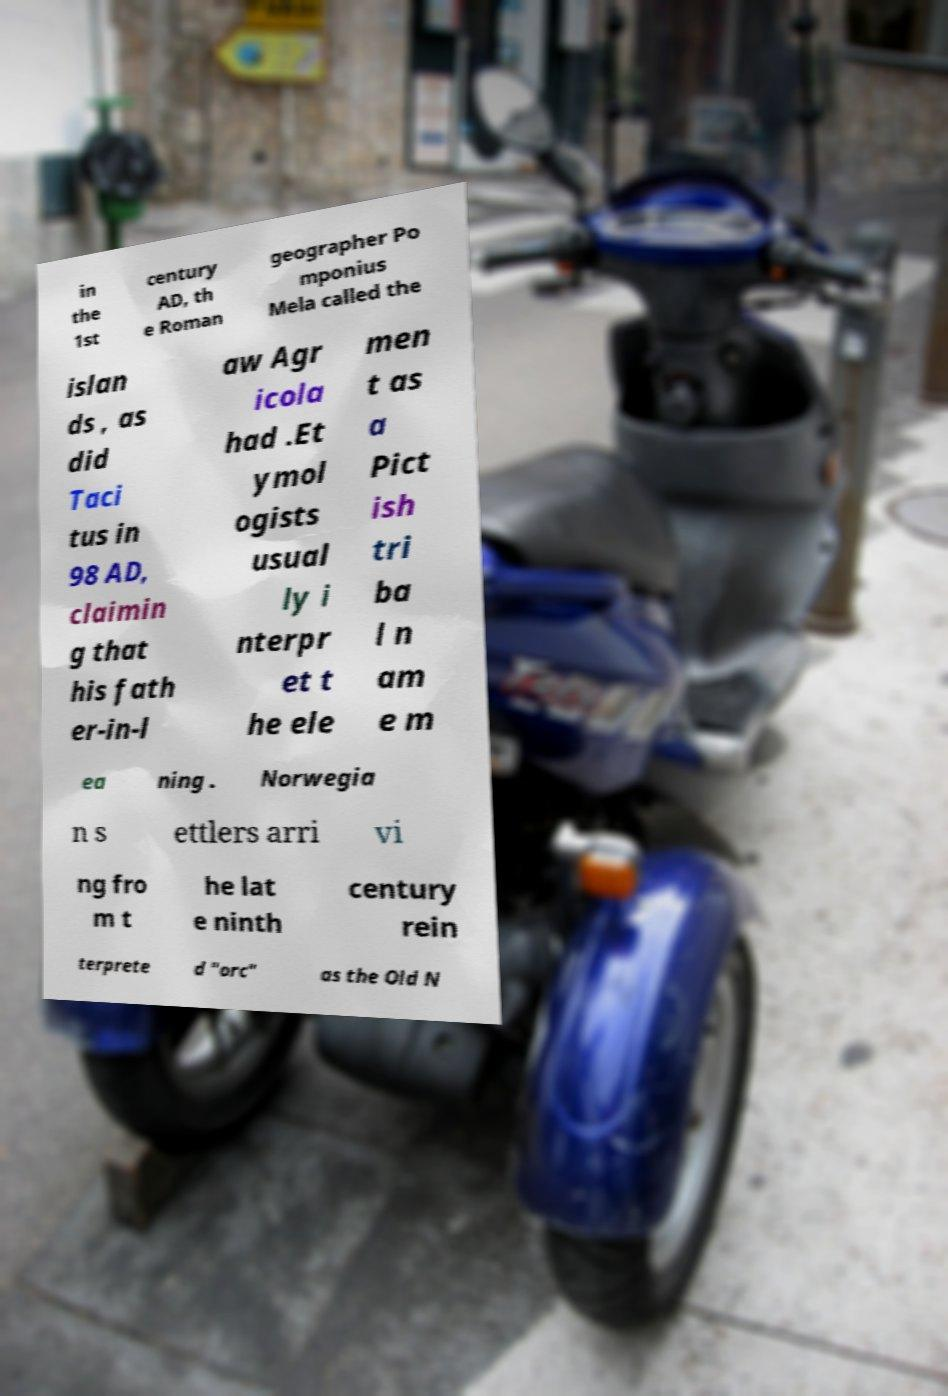Could you assist in decoding the text presented in this image and type it out clearly? in the 1st century AD, th e Roman geographer Po mponius Mela called the islan ds , as did Taci tus in 98 AD, claimin g that his fath er-in-l aw Agr icola had .Et ymol ogists usual ly i nterpr et t he ele men t as a Pict ish tri ba l n am e m ea ning . Norwegia n s ettlers arri vi ng fro m t he lat e ninth century rein terprete d "orc" as the Old N 